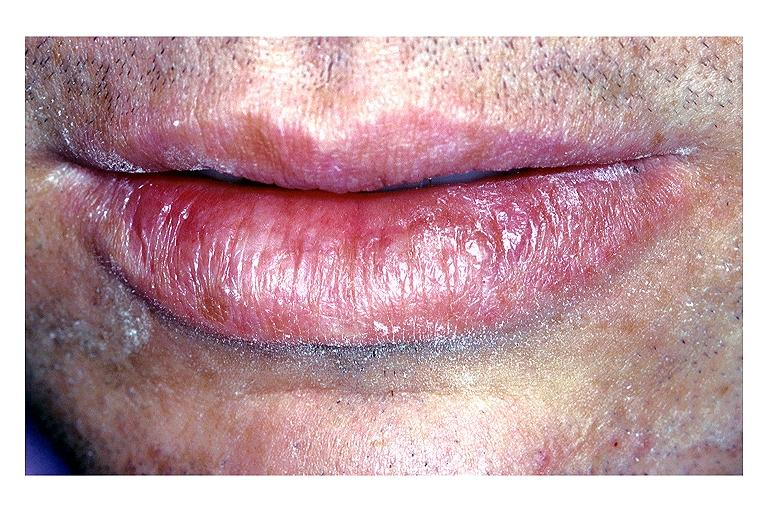s oral present?
Answer the question using a single word or phrase. Yes 